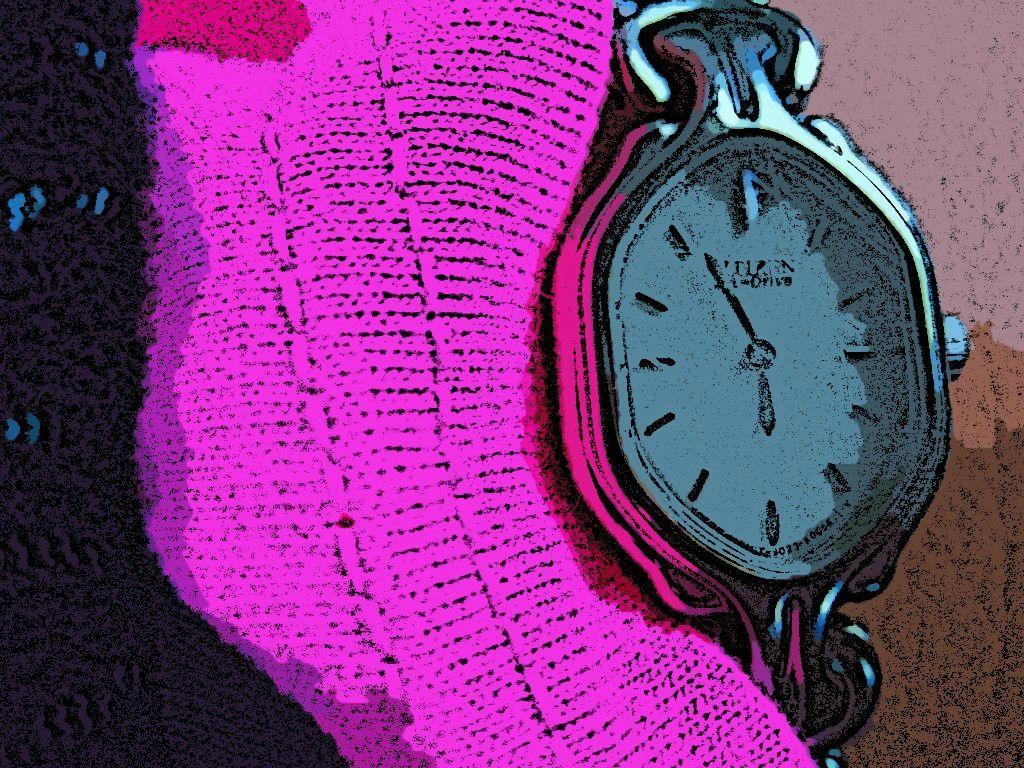What is the main subject of the painting in the image? There is a painting of a watch in the image. What color is the cloth visible in the image? The cloth in the image is pink. How would you describe the background of the image? The background of the image is completely dark. Can you see any holes in the sidewalk in the image? There is no sidewalk present in the image, so it is not possible to see any holes in it. 